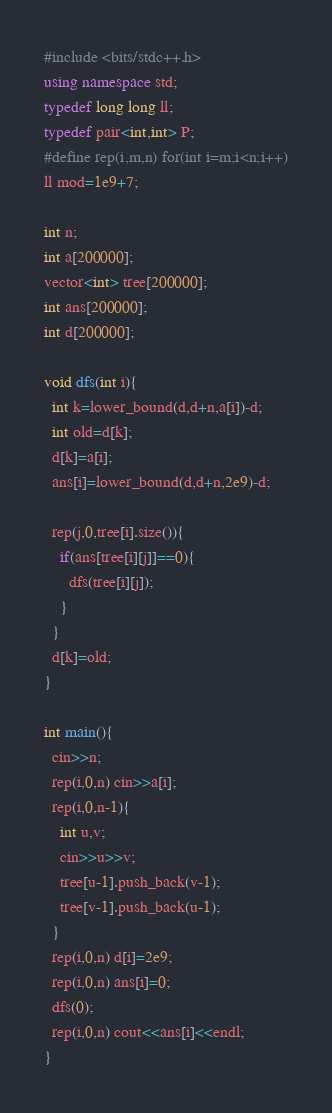<code> <loc_0><loc_0><loc_500><loc_500><_C++_>#include <bits/stdc++.h>
using namespace std;
typedef long long ll;
typedef pair<int,int> P;
#define rep(i,m,n) for(int i=m;i<n;i++)
ll mod=1e9+7;

int n;
int a[200000];
vector<int> tree[200000];
int ans[200000];
int d[200000];

void dfs(int i){
  int k=lower_bound(d,d+n,a[i])-d;
  int old=d[k];
  d[k]=a[i];
  ans[i]=lower_bound(d,d+n,2e9)-d;
  
  rep(j,0,tree[i].size()){
    if(ans[tree[i][j]]==0){
      dfs(tree[i][j]);
    }
  }
  d[k]=old;
}

int main(){
  cin>>n;
  rep(i,0,n) cin>>a[i];
  rep(i,0,n-1){
    int u,v;
    cin>>u>>v;
    tree[u-1].push_back(v-1);
    tree[v-1].push_back(u-1);
  }
  rep(i,0,n) d[i]=2e9;
  rep(i,0,n) ans[i]=0;
  dfs(0);
  rep(i,0,n) cout<<ans[i]<<endl;
}</code> 